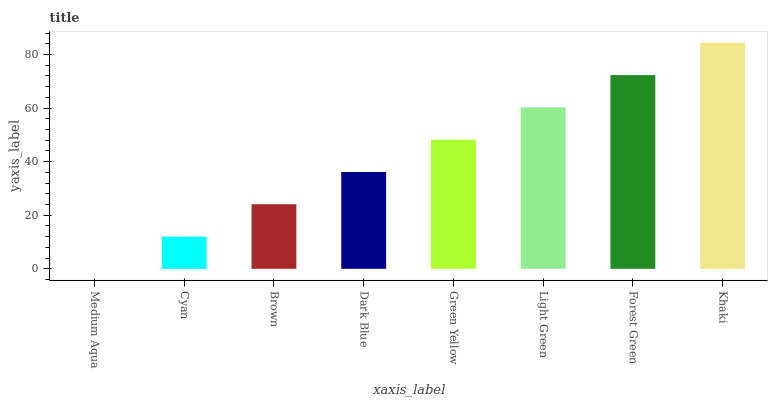Is Medium Aqua the minimum?
Answer yes or no. Yes. Is Khaki the maximum?
Answer yes or no. Yes. Is Cyan the minimum?
Answer yes or no. No. Is Cyan the maximum?
Answer yes or no. No. Is Cyan greater than Medium Aqua?
Answer yes or no. Yes. Is Medium Aqua less than Cyan?
Answer yes or no. Yes. Is Medium Aqua greater than Cyan?
Answer yes or no. No. Is Cyan less than Medium Aqua?
Answer yes or no. No. Is Green Yellow the high median?
Answer yes or no. Yes. Is Dark Blue the low median?
Answer yes or no. Yes. Is Brown the high median?
Answer yes or no. No. Is Forest Green the low median?
Answer yes or no. No. 